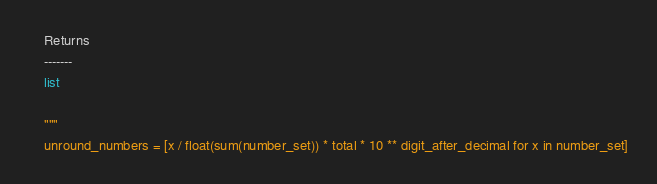<code> <loc_0><loc_0><loc_500><loc_500><_Python_>
    Returns
    -------
    list

    """
    unround_numbers = [x / float(sum(number_set)) * total * 10 ** digit_after_decimal for x in number_set]</code> 